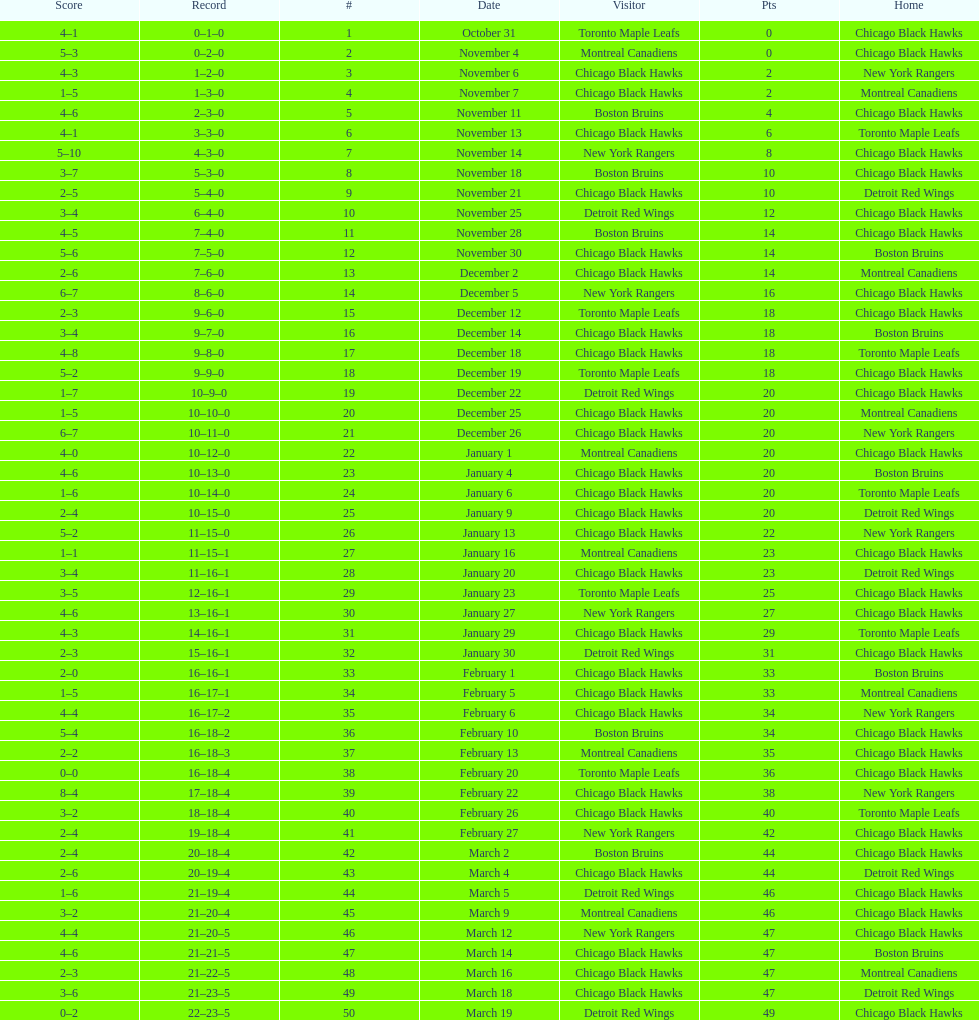What is the difference in pts between december 5th and november 11th? 3. 